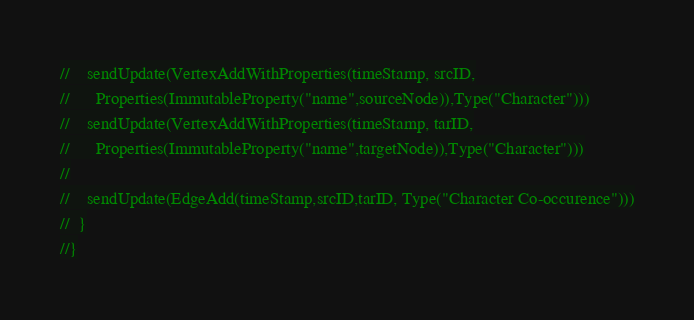Convert code to text. <code><loc_0><loc_0><loc_500><loc_500><_Scala_>//    sendUpdate(VertexAddWithProperties(timeStamp, srcID,
//      Properties(ImmutableProperty("name",sourceNode)),Type("Character")))
//    sendUpdate(VertexAddWithProperties(timeStamp, tarID,
//      Properties(ImmutableProperty("name",targetNode)),Type("Character")))
//
//    sendUpdate(EdgeAdd(timeStamp,srcID,tarID, Type("Character Co-occurence")))
//  }
//}
</code> 